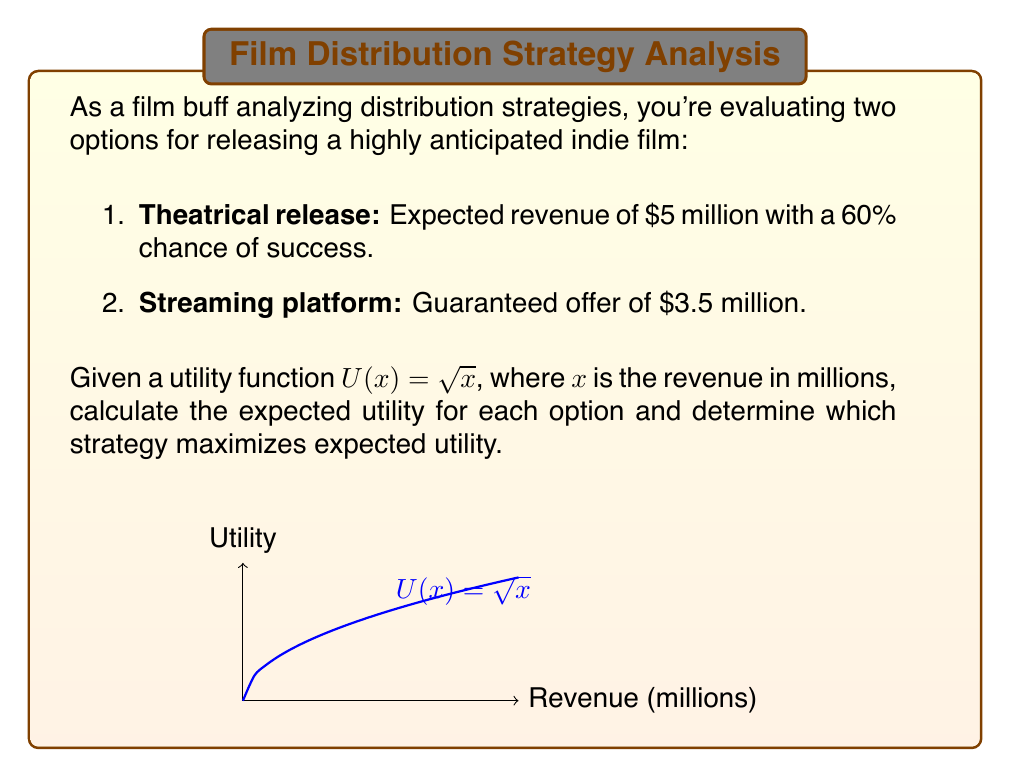Show me your answer to this math problem. Let's approach this step-by-step:

1) For the theatrical release:
   - Success scenario: 60% chance of $5 million
   - Failure scenario: 40% chance of $0 (assuming no revenue if it fails)

2) Calculate the utility for each scenario:
   - Success: $U(5) = \sqrt{5} \approx 2.236$
   - Failure: $U(0) = \sqrt{0} = 0$

3) Calculate the expected utility for theatrical release:
   $$E[U_{theatrical}] = 0.6 \cdot \sqrt{5} + 0.4 \cdot 0 = 0.6 \cdot 2.236 \approx 1.342$$

4) For the streaming platform:
   - Guaranteed $3.5 million

5) Calculate the utility for streaming:
   $$U(3.5) = \sqrt{3.5} \approx 1.871$$

6) The expected utility for streaming is the same as its utility, as it's guaranteed:
   $$E[U_{streaming}] = 1.871$$

7) Compare the expected utilities:
   - Theatrical: 1.342
   - Streaming: 1.871

8) The strategy that maximizes expected utility is the one with the higher value.
Answer: Streaming platform (1.871 > 1.342) 